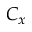<formula> <loc_0><loc_0><loc_500><loc_500>C _ { x }</formula> 